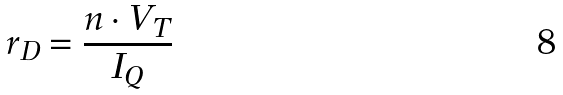<formula> <loc_0><loc_0><loc_500><loc_500>r _ { D } = \frac { n \cdot V _ { T } } { I _ { Q } }</formula> 